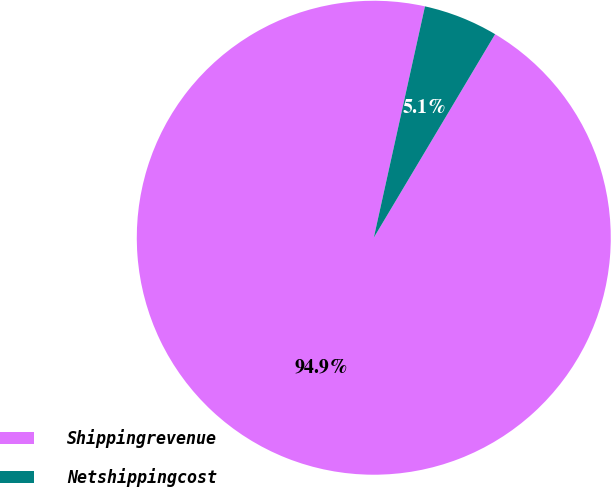Convert chart to OTSL. <chart><loc_0><loc_0><loc_500><loc_500><pie_chart><fcel>Shippingrevenue<fcel>Netshippingcost<nl><fcel>94.91%<fcel>5.09%<nl></chart> 